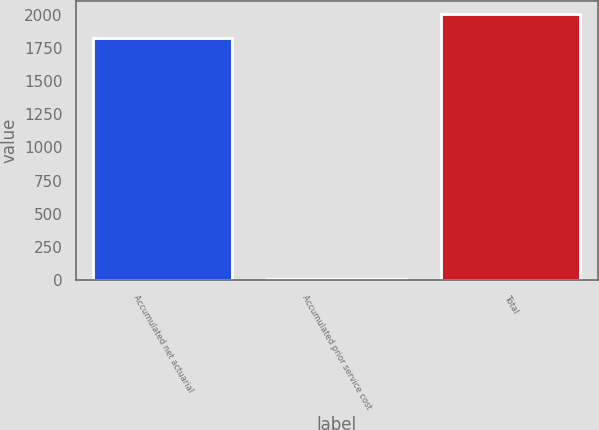Convert chart. <chart><loc_0><loc_0><loc_500><loc_500><bar_chart><fcel>Accumulated net actuarial<fcel>Accumulated prior service cost<fcel>Total<nl><fcel>1824<fcel>3<fcel>2006.4<nl></chart> 